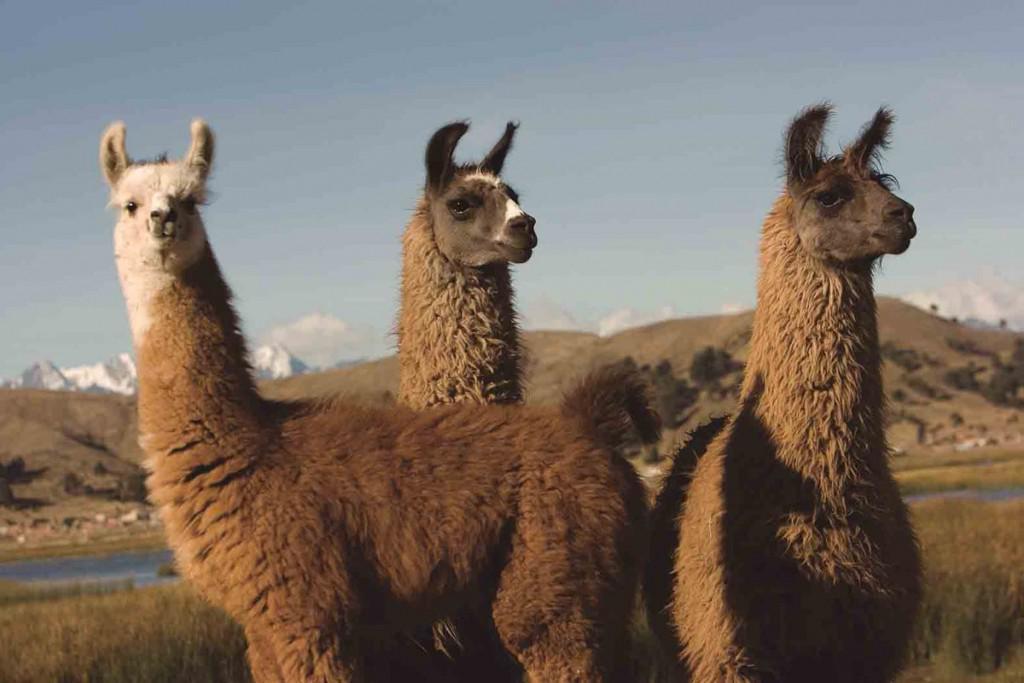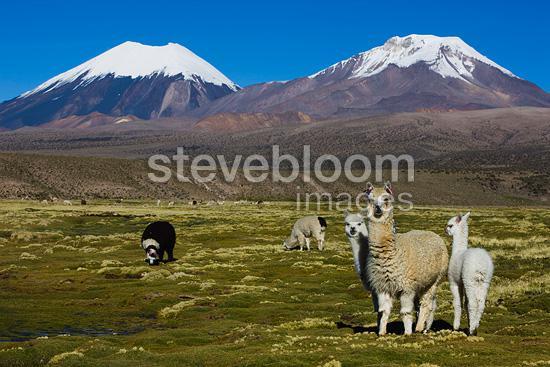The first image is the image on the left, the second image is the image on the right. Assess this claim about the two images: "One image shows a single brownish llama with its head angled rightward and red tassles on the ends of its dark upright ears.". Correct or not? Answer yes or no. No. The first image is the image on the left, the second image is the image on the right. Examine the images to the left and right. Is the description "an alpaca has tassles dangling from its ears" accurate? Answer yes or no. No. 